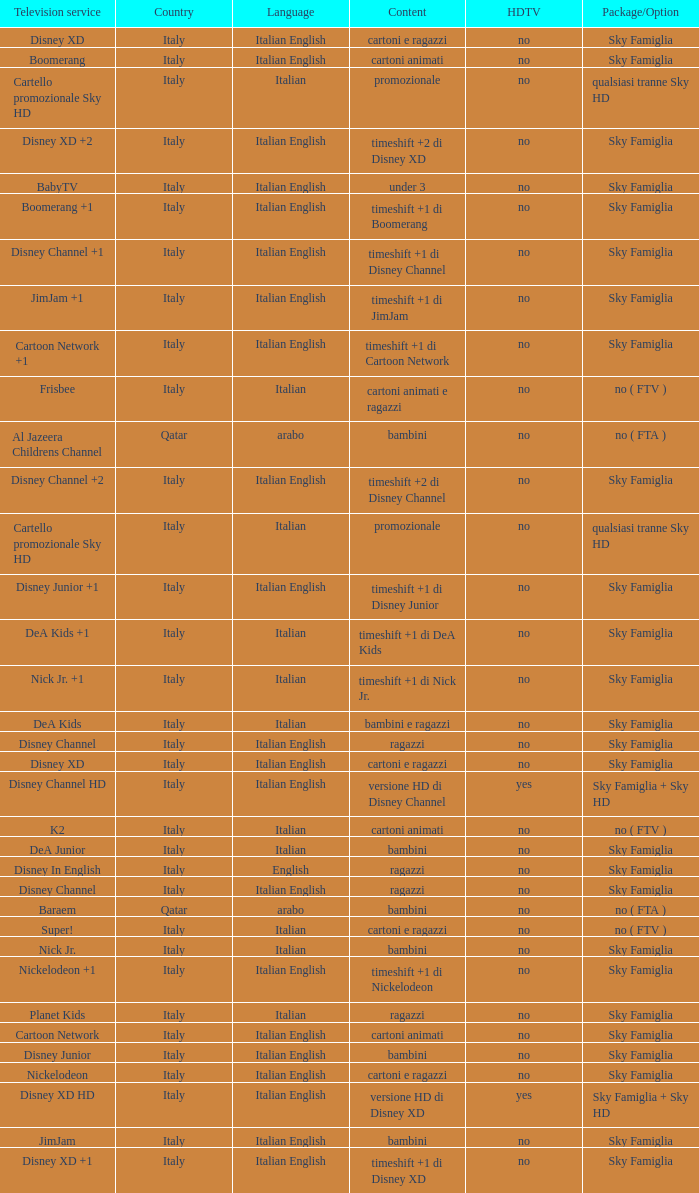What is the Country when the language is italian english, and the television service is disney xd +1? Italy. Help me parse the entirety of this table. {'header': ['Television service', 'Country', 'Language', 'Content', 'HDTV', 'Package/Option'], 'rows': [['Disney XD', 'Italy', 'Italian English', 'cartoni e ragazzi', 'no', 'Sky Famiglia'], ['Boomerang', 'Italy', 'Italian English', 'cartoni animati', 'no', 'Sky Famiglia'], ['Cartello promozionale Sky HD', 'Italy', 'Italian', 'promozionale', 'no', 'qualsiasi tranne Sky HD'], ['Disney XD +2', 'Italy', 'Italian English', 'timeshift +2 di Disney XD', 'no', 'Sky Famiglia'], ['BabyTV', 'Italy', 'Italian English', 'under 3', 'no', 'Sky Famiglia'], ['Boomerang +1', 'Italy', 'Italian English', 'timeshift +1 di Boomerang', 'no', 'Sky Famiglia'], ['Disney Channel +1', 'Italy', 'Italian English', 'timeshift +1 di Disney Channel', 'no', 'Sky Famiglia'], ['JimJam +1', 'Italy', 'Italian English', 'timeshift +1 di JimJam', 'no', 'Sky Famiglia'], ['Cartoon Network +1', 'Italy', 'Italian English', 'timeshift +1 di Cartoon Network', 'no', 'Sky Famiglia'], ['Frisbee', 'Italy', 'Italian', 'cartoni animati e ragazzi', 'no', 'no ( FTV )'], ['Al Jazeera Childrens Channel', 'Qatar', 'arabo', 'bambini', 'no', 'no ( FTA )'], ['Disney Channel +2', 'Italy', 'Italian English', 'timeshift +2 di Disney Channel', 'no', 'Sky Famiglia'], ['Cartello promozionale Sky HD', 'Italy', 'Italian', 'promozionale', 'no', 'qualsiasi tranne Sky HD'], ['Disney Junior +1', 'Italy', 'Italian English', 'timeshift +1 di Disney Junior', 'no', 'Sky Famiglia'], ['DeA Kids +1', 'Italy', 'Italian', 'timeshift +1 di DeA Kids', 'no', 'Sky Famiglia'], ['Nick Jr. +1', 'Italy', 'Italian', 'timeshift +1 di Nick Jr.', 'no', 'Sky Famiglia'], ['DeA Kids', 'Italy', 'Italian', 'bambini e ragazzi', 'no', 'Sky Famiglia'], ['Disney Channel', 'Italy', 'Italian English', 'ragazzi', 'no', 'Sky Famiglia'], ['Disney XD', 'Italy', 'Italian English', 'cartoni e ragazzi', 'no', 'Sky Famiglia'], ['Disney Channel HD', 'Italy', 'Italian English', 'versione HD di Disney Channel', 'yes', 'Sky Famiglia + Sky HD'], ['K2', 'Italy', 'Italian', 'cartoni animati', 'no', 'no ( FTV )'], ['DeA Junior', 'Italy', 'Italian', 'bambini', 'no', 'Sky Famiglia'], ['Disney In English', 'Italy', 'English', 'ragazzi', 'no', 'Sky Famiglia'], ['Disney Channel', 'Italy', 'Italian English', 'ragazzi', 'no', 'Sky Famiglia'], ['Baraem', 'Qatar', 'arabo', 'bambini', 'no', 'no ( FTA )'], ['Super!', 'Italy', 'Italian', 'cartoni e ragazzi', 'no', 'no ( FTV )'], ['Nick Jr.', 'Italy', 'Italian', 'bambini', 'no', 'Sky Famiglia'], ['Nickelodeon +1', 'Italy', 'Italian English', 'timeshift +1 di Nickelodeon', 'no', 'Sky Famiglia'], ['Planet Kids', 'Italy', 'Italian', 'ragazzi', 'no', 'Sky Famiglia'], ['Cartoon Network', 'Italy', 'Italian English', 'cartoni animati', 'no', 'Sky Famiglia'], ['Disney Junior', 'Italy', 'Italian English', 'bambini', 'no', 'Sky Famiglia'], ['Nickelodeon', 'Italy', 'Italian English', 'cartoni e ragazzi', 'no', 'Sky Famiglia'], ['Disney XD HD', 'Italy', 'Italian English', 'versione HD di Disney XD', 'yes', 'Sky Famiglia + Sky HD'], ['JimJam', 'Italy', 'Italian English', 'bambini', 'no', 'Sky Famiglia'], ['Disney XD +1', 'Italy', 'Italian English', 'timeshift +1 di Disney XD', 'no', 'Sky Famiglia']]} 